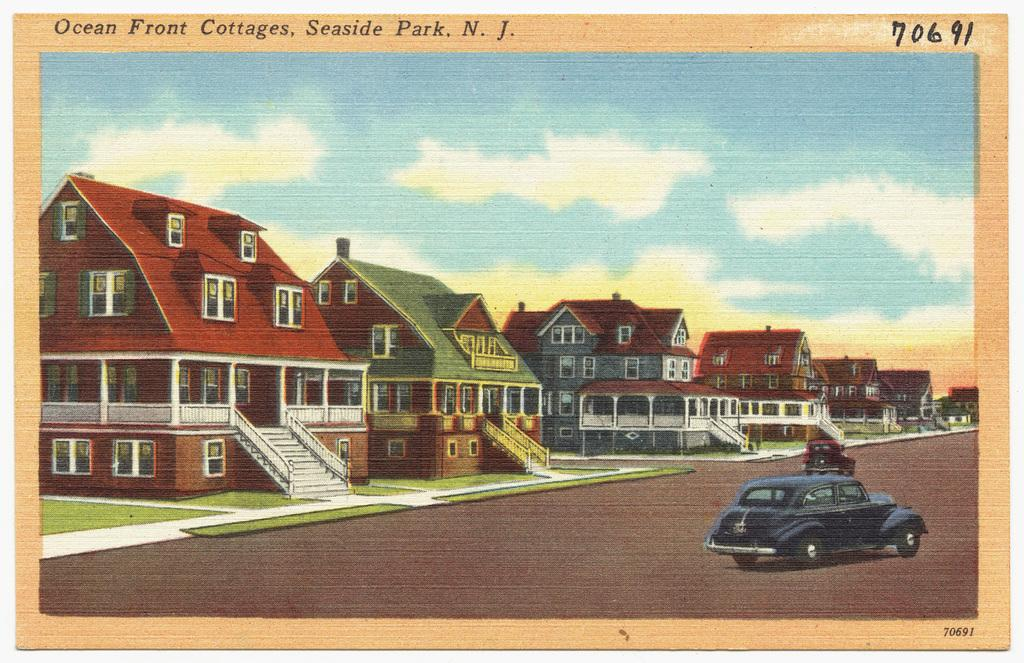What type of structures can be seen in the image? There are buildings in the image. What architectural feature is present in the image? There are stairs and a railing in the image. What type of transportation can be seen on the road in the image? Vehicles are visible on the road in the image. What is visible in the sky in the image? There are clouds in the sky in the image. Is there any text present in the image? Yes, there is some text visible in the image. What type of sugar is being used to sweeten the spade in the image? There is no sugar or spade present in the image. On which side of the building is the door located in the image? The provided facts do not specify the location of a door on the building in the image. 